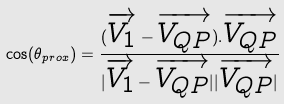Convert formula to latex. <formula><loc_0><loc_0><loc_500><loc_500>\cos ( \theta _ { p r o x } ) = \frac { ( \overrightarrow { V _ { 1 } } - \overrightarrow { V _ { Q P } } ) . \overrightarrow { V _ { Q P } } } { | \overrightarrow { V _ { 1 } } - \overrightarrow { V _ { Q P } } | | \overrightarrow { V _ { Q P } } | }</formula> 